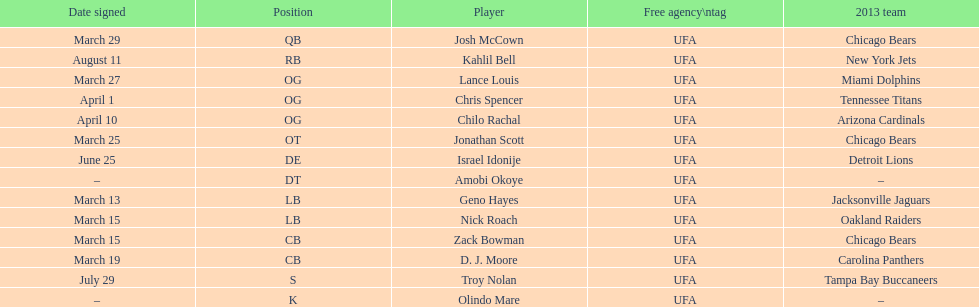How many players were signed in march? 7. 